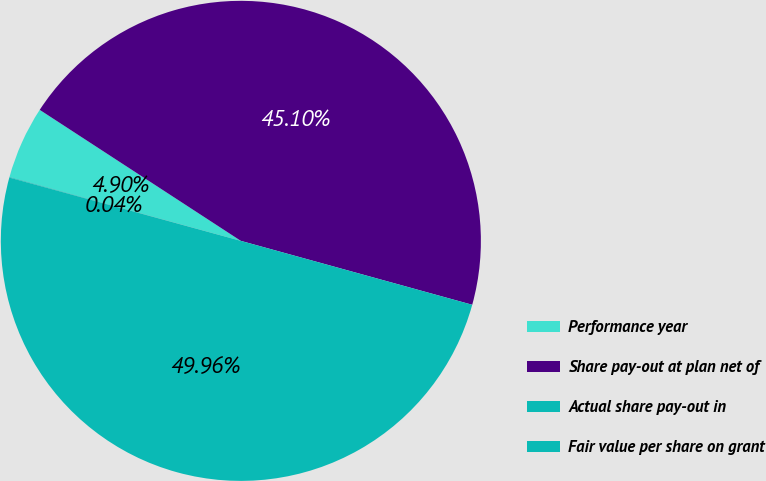<chart> <loc_0><loc_0><loc_500><loc_500><pie_chart><fcel>Performance year<fcel>Share pay-out at plan net of<fcel>Actual share pay-out in<fcel>Fair value per share on grant<nl><fcel>4.9%<fcel>45.1%<fcel>49.96%<fcel>0.04%<nl></chart> 